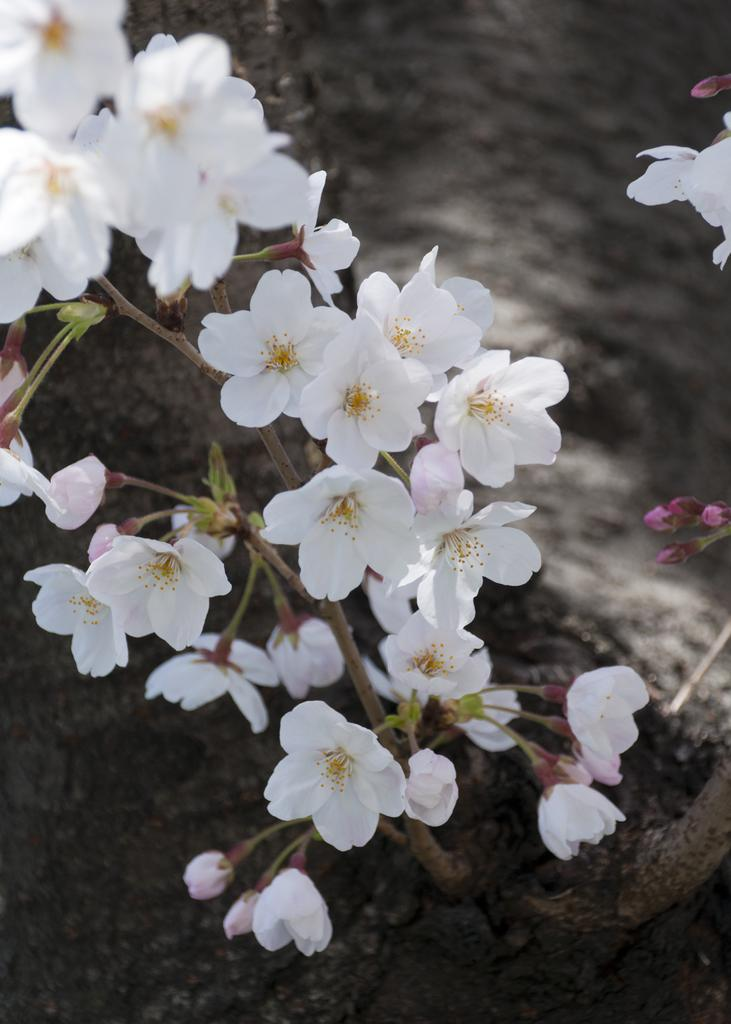What is the main subject in the center of the image? There is a flower plant in the center of the image. What can be seen at the bottom of the image? There is soil at the bottom of the image. What are the men teaching in the image? There are no men or teaching activities present in the image; it features a flower plant and soil. 